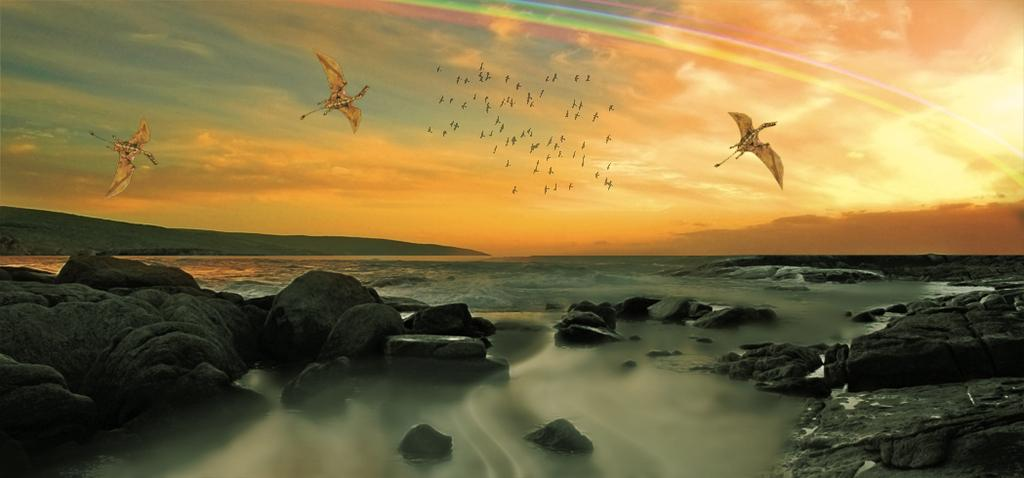What is happening in the image involving animals? There are birds flying in the image. What type of natural formations can be seen in the image? There are rocks, mountains, and water visible in the image. What is visible in the background of the image? The sky is visible in the background of the image, with clouds present. Can you see a nut being cracked by a bear in the image? There is no bear or nut present in the image. How many bear cubs are visible in the image? There are no bear cubs present in the image. 